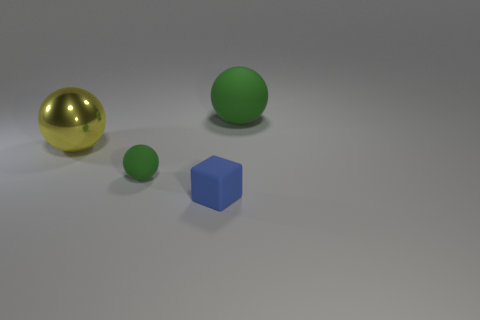Are there any reflections visible on the surfaces of the objects? Yes, reflections can be observed on the objects. The large metal sphere has a strong reflective surface, showcasing the environment and the light source. The other objects have a more diffused reflection due to their matte material properties, so their reflections are less distinct and more subtle. 